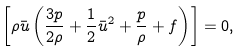<formula> <loc_0><loc_0><loc_500><loc_500>\left [ \rho \bar { u } \left ( \frac { 3 p } { 2 \rho } + \frac { 1 } { 2 } \bar { u } ^ { 2 } + \frac { p } { \rho } + f \right ) \right ] = 0 ,</formula> 